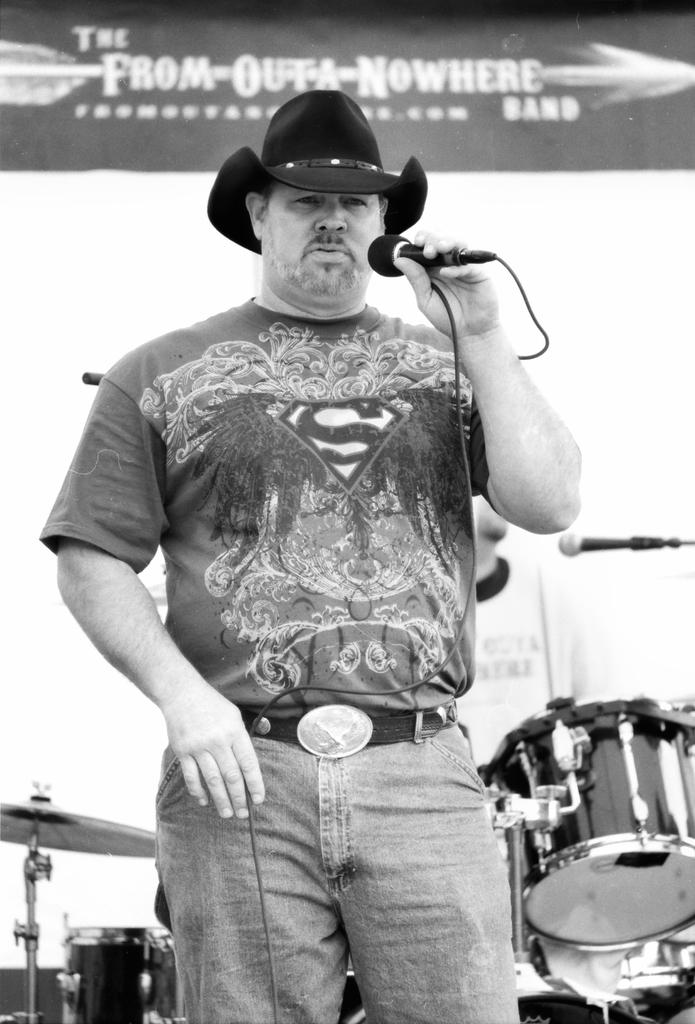Who is the main subject in the image? There is a man in the image. What is the man holding in the image? The man is holding a microphone. What is the man wearing in the image? The man is wearing clothes and a hat. What else can be seen in the image besides the man? There are musical instruments in the image. What type of division is the man performing with the rifle in the image? There is no rifle present in the image, and the man is not performing any divisions. 